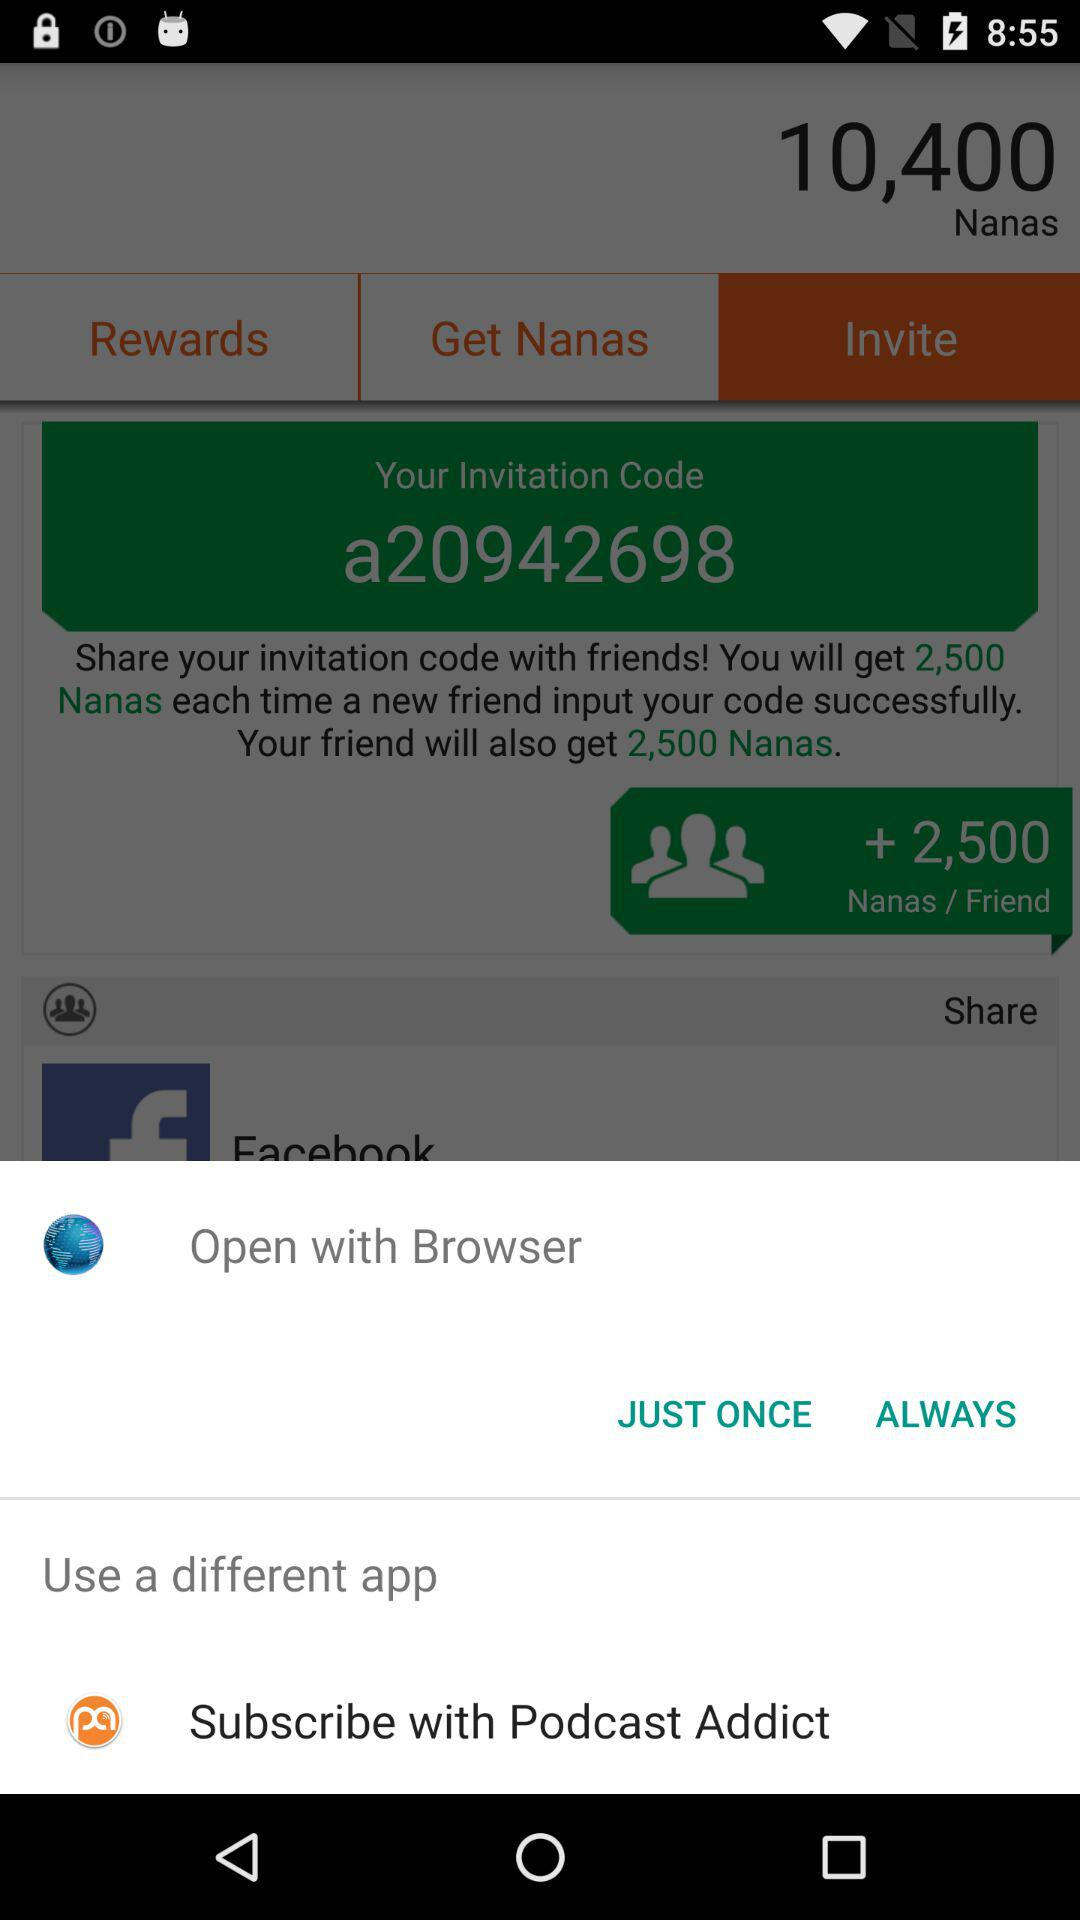How many "Nanas" are there? There are 10,400 nanas. 